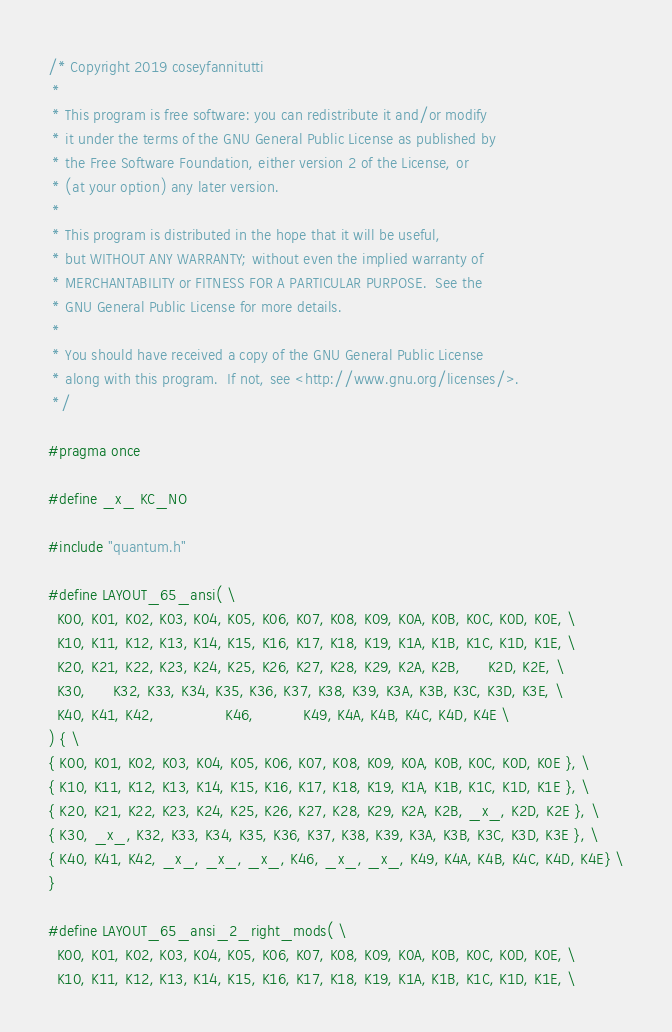<code> <loc_0><loc_0><loc_500><loc_500><_C_>/* Copyright 2019 coseyfannitutti
 *
 * This program is free software: you can redistribute it and/or modify
 * it under the terms of the GNU General Public License as published by
 * the Free Software Foundation, either version 2 of the License, or
 * (at your option) any later version.
 *
 * This program is distributed in the hope that it will be useful,
 * but WITHOUT ANY WARRANTY; without even the implied warranty of
 * MERCHANTABILITY or FITNESS FOR A PARTICULAR PURPOSE.  See the
 * GNU General Public License for more details.
 *
 * You should have received a copy of the GNU General Public License
 * along with this program.  If not, see <http://www.gnu.org/licenses/>.
 */

#pragma once

#define _x_ KC_NO

#include "quantum.h"

#define LAYOUT_65_ansi( \
  K00, K01, K02, K03, K04, K05, K06, K07, K08, K09, K0A, K0B, K0C, K0D, K0E, \
  K10, K11, K12, K13, K14, K15, K16, K17, K18, K19, K1A, K1B, K1C, K1D, K1E, \
  K20, K21, K22, K23, K24, K25, K26, K27, K28, K29, K2A, K2B,      K2D, K2E, \
  K30,      K32, K33, K34, K35, K36, K37, K38, K39, K3A, K3B, K3C, K3D, K3E, \
  K40, K41, K42,                K46,           K49, K4A, K4B, K4C, K4D, K4E \
) { \
{ K00, K01, K02, K03, K04, K05, K06, K07, K08, K09, K0A, K0B, K0C, K0D, K0E }, \
{ K10, K11, K12, K13, K14, K15, K16, K17, K18, K19, K1A, K1B, K1C, K1D, K1E }, \
{ K20, K21, K22, K23, K24, K25, K26, K27, K28, K29, K2A, K2B, _x_, K2D, K2E }, \
{ K30, _x_, K32, K33, K34, K35, K36, K37, K38, K39, K3A, K3B, K3C, K3D, K3E }, \
{ K40, K41, K42, _x_, _x_, _x_, K46, _x_, _x_, K49, K4A, K4B, K4C, K4D, K4E} \
}

#define LAYOUT_65_ansi_2_right_mods( \
  K00, K01, K02, K03, K04, K05, K06, K07, K08, K09, K0A, K0B, K0C, K0D, K0E, \
  K10, K11, K12, K13, K14, K15, K16, K17, K18, K19, K1A, K1B, K1C, K1D, K1E, \</code> 